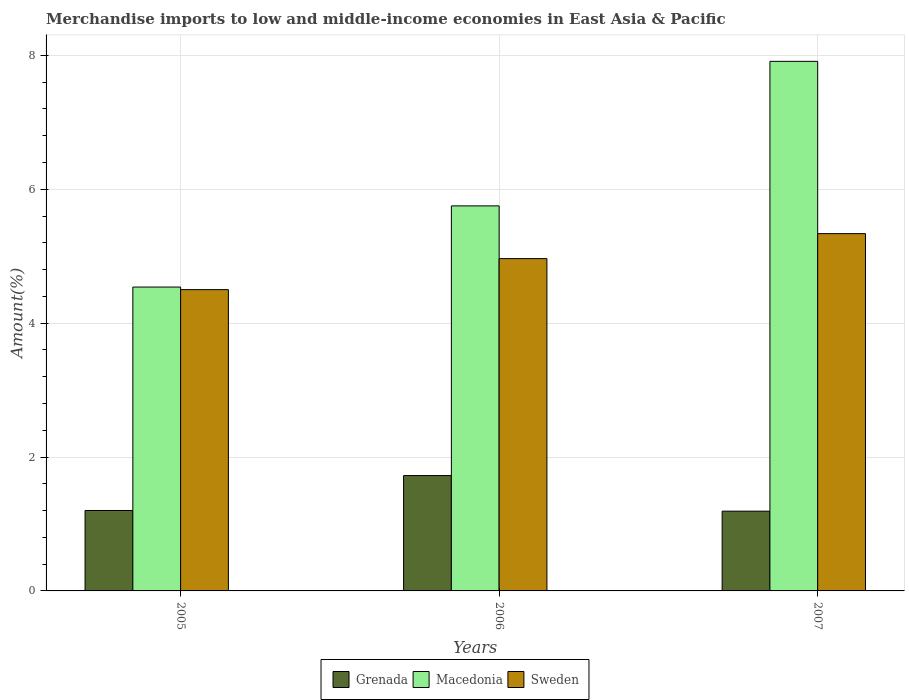Are the number of bars per tick equal to the number of legend labels?
Give a very brief answer. Yes. What is the label of the 2nd group of bars from the left?
Keep it short and to the point. 2006. What is the percentage of amount earned from merchandise imports in Sweden in 2005?
Provide a succinct answer. 4.5. Across all years, what is the maximum percentage of amount earned from merchandise imports in Sweden?
Your answer should be compact. 5.34. Across all years, what is the minimum percentage of amount earned from merchandise imports in Grenada?
Your answer should be compact. 1.19. What is the total percentage of amount earned from merchandise imports in Grenada in the graph?
Your answer should be very brief. 4.12. What is the difference between the percentage of amount earned from merchandise imports in Sweden in 2005 and that in 2007?
Keep it short and to the point. -0.84. What is the difference between the percentage of amount earned from merchandise imports in Sweden in 2005 and the percentage of amount earned from merchandise imports in Macedonia in 2006?
Your answer should be compact. -1.25. What is the average percentage of amount earned from merchandise imports in Grenada per year?
Make the answer very short. 1.37. In the year 2006, what is the difference between the percentage of amount earned from merchandise imports in Macedonia and percentage of amount earned from merchandise imports in Sweden?
Give a very brief answer. 0.79. What is the ratio of the percentage of amount earned from merchandise imports in Macedonia in 2006 to that in 2007?
Provide a succinct answer. 0.73. What is the difference between the highest and the second highest percentage of amount earned from merchandise imports in Sweden?
Offer a terse response. 0.37. What is the difference between the highest and the lowest percentage of amount earned from merchandise imports in Sweden?
Provide a succinct answer. 0.84. Is the sum of the percentage of amount earned from merchandise imports in Macedonia in 2005 and 2006 greater than the maximum percentage of amount earned from merchandise imports in Grenada across all years?
Provide a short and direct response. Yes. What does the 2nd bar from the left in 2007 represents?
Your response must be concise. Macedonia. What does the 2nd bar from the right in 2006 represents?
Give a very brief answer. Macedonia. How many bars are there?
Provide a succinct answer. 9. Are all the bars in the graph horizontal?
Offer a terse response. No. Are the values on the major ticks of Y-axis written in scientific E-notation?
Provide a short and direct response. No. How many legend labels are there?
Your response must be concise. 3. How are the legend labels stacked?
Provide a succinct answer. Horizontal. What is the title of the graph?
Your answer should be compact. Merchandise imports to low and middle-income economies in East Asia & Pacific. What is the label or title of the Y-axis?
Your answer should be very brief. Amount(%). What is the Amount(%) in Grenada in 2005?
Your answer should be compact. 1.2. What is the Amount(%) in Macedonia in 2005?
Provide a succinct answer. 4.54. What is the Amount(%) of Sweden in 2005?
Give a very brief answer. 4.5. What is the Amount(%) in Grenada in 2006?
Ensure brevity in your answer.  1.72. What is the Amount(%) of Macedonia in 2006?
Offer a very short reply. 5.75. What is the Amount(%) of Sweden in 2006?
Your answer should be very brief. 4.96. What is the Amount(%) in Grenada in 2007?
Provide a short and direct response. 1.19. What is the Amount(%) in Macedonia in 2007?
Provide a short and direct response. 7.91. What is the Amount(%) in Sweden in 2007?
Provide a succinct answer. 5.34. Across all years, what is the maximum Amount(%) of Grenada?
Your response must be concise. 1.72. Across all years, what is the maximum Amount(%) of Macedonia?
Offer a terse response. 7.91. Across all years, what is the maximum Amount(%) of Sweden?
Your answer should be compact. 5.34. Across all years, what is the minimum Amount(%) in Grenada?
Ensure brevity in your answer.  1.19. Across all years, what is the minimum Amount(%) of Macedonia?
Provide a short and direct response. 4.54. Across all years, what is the minimum Amount(%) in Sweden?
Your answer should be very brief. 4.5. What is the total Amount(%) of Grenada in the graph?
Provide a succinct answer. 4.12. What is the total Amount(%) in Macedonia in the graph?
Your response must be concise. 18.2. What is the total Amount(%) of Sweden in the graph?
Offer a terse response. 14.8. What is the difference between the Amount(%) in Grenada in 2005 and that in 2006?
Ensure brevity in your answer.  -0.52. What is the difference between the Amount(%) in Macedonia in 2005 and that in 2006?
Ensure brevity in your answer.  -1.21. What is the difference between the Amount(%) in Sweden in 2005 and that in 2006?
Provide a short and direct response. -0.46. What is the difference between the Amount(%) of Grenada in 2005 and that in 2007?
Ensure brevity in your answer.  0.01. What is the difference between the Amount(%) of Macedonia in 2005 and that in 2007?
Offer a terse response. -3.37. What is the difference between the Amount(%) of Sweden in 2005 and that in 2007?
Your answer should be very brief. -0.84. What is the difference between the Amount(%) in Grenada in 2006 and that in 2007?
Your answer should be compact. 0.53. What is the difference between the Amount(%) of Macedonia in 2006 and that in 2007?
Offer a terse response. -2.16. What is the difference between the Amount(%) of Sweden in 2006 and that in 2007?
Ensure brevity in your answer.  -0.37. What is the difference between the Amount(%) in Grenada in 2005 and the Amount(%) in Macedonia in 2006?
Provide a short and direct response. -4.55. What is the difference between the Amount(%) of Grenada in 2005 and the Amount(%) of Sweden in 2006?
Your answer should be very brief. -3.76. What is the difference between the Amount(%) of Macedonia in 2005 and the Amount(%) of Sweden in 2006?
Offer a terse response. -0.43. What is the difference between the Amount(%) of Grenada in 2005 and the Amount(%) of Macedonia in 2007?
Make the answer very short. -6.71. What is the difference between the Amount(%) in Grenada in 2005 and the Amount(%) in Sweden in 2007?
Provide a succinct answer. -4.14. What is the difference between the Amount(%) of Macedonia in 2005 and the Amount(%) of Sweden in 2007?
Offer a very short reply. -0.8. What is the difference between the Amount(%) in Grenada in 2006 and the Amount(%) in Macedonia in 2007?
Give a very brief answer. -6.19. What is the difference between the Amount(%) of Grenada in 2006 and the Amount(%) of Sweden in 2007?
Offer a terse response. -3.61. What is the difference between the Amount(%) in Macedonia in 2006 and the Amount(%) in Sweden in 2007?
Ensure brevity in your answer.  0.41. What is the average Amount(%) of Grenada per year?
Ensure brevity in your answer.  1.37. What is the average Amount(%) of Macedonia per year?
Offer a very short reply. 6.07. What is the average Amount(%) of Sweden per year?
Provide a succinct answer. 4.93. In the year 2005, what is the difference between the Amount(%) of Grenada and Amount(%) of Macedonia?
Provide a succinct answer. -3.34. In the year 2005, what is the difference between the Amount(%) in Grenada and Amount(%) in Sweden?
Provide a succinct answer. -3.3. In the year 2005, what is the difference between the Amount(%) in Macedonia and Amount(%) in Sweden?
Make the answer very short. 0.04. In the year 2006, what is the difference between the Amount(%) in Grenada and Amount(%) in Macedonia?
Make the answer very short. -4.03. In the year 2006, what is the difference between the Amount(%) of Grenada and Amount(%) of Sweden?
Your answer should be compact. -3.24. In the year 2006, what is the difference between the Amount(%) of Macedonia and Amount(%) of Sweden?
Provide a succinct answer. 0.79. In the year 2007, what is the difference between the Amount(%) in Grenada and Amount(%) in Macedonia?
Your answer should be compact. -6.72. In the year 2007, what is the difference between the Amount(%) of Grenada and Amount(%) of Sweden?
Offer a very short reply. -4.15. In the year 2007, what is the difference between the Amount(%) of Macedonia and Amount(%) of Sweden?
Provide a short and direct response. 2.57. What is the ratio of the Amount(%) in Grenada in 2005 to that in 2006?
Ensure brevity in your answer.  0.7. What is the ratio of the Amount(%) of Macedonia in 2005 to that in 2006?
Your answer should be compact. 0.79. What is the ratio of the Amount(%) of Sweden in 2005 to that in 2006?
Offer a terse response. 0.91. What is the ratio of the Amount(%) of Grenada in 2005 to that in 2007?
Give a very brief answer. 1.01. What is the ratio of the Amount(%) of Macedonia in 2005 to that in 2007?
Give a very brief answer. 0.57. What is the ratio of the Amount(%) of Sweden in 2005 to that in 2007?
Make the answer very short. 0.84. What is the ratio of the Amount(%) in Grenada in 2006 to that in 2007?
Provide a succinct answer. 1.45. What is the ratio of the Amount(%) of Macedonia in 2006 to that in 2007?
Ensure brevity in your answer.  0.73. What is the ratio of the Amount(%) in Sweden in 2006 to that in 2007?
Ensure brevity in your answer.  0.93. What is the difference between the highest and the second highest Amount(%) of Grenada?
Make the answer very short. 0.52. What is the difference between the highest and the second highest Amount(%) in Macedonia?
Your answer should be compact. 2.16. What is the difference between the highest and the second highest Amount(%) of Sweden?
Give a very brief answer. 0.37. What is the difference between the highest and the lowest Amount(%) in Grenada?
Offer a very short reply. 0.53. What is the difference between the highest and the lowest Amount(%) in Macedonia?
Give a very brief answer. 3.37. What is the difference between the highest and the lowest Amount(%) of Sweden?
Provide a short and direct response. 0.84. 